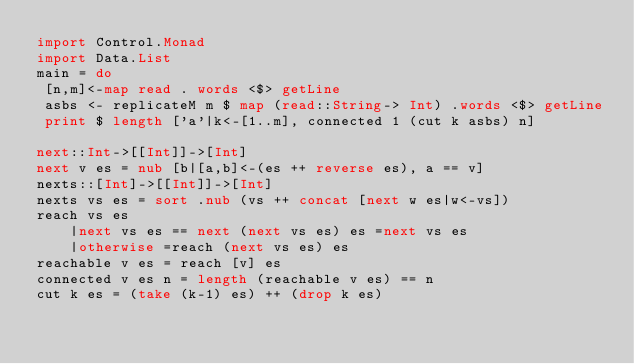<code> <loc_0><loc_0><loc_500><loc_500><_Haskell_>import Control.Monad
import Data.List
main = do
 [n,m]<-map read . words <$> getLine
 asbs <- replicateM m $ map (read::String-> Int) .words <$> getLine
 print $ length ['a'|k<-[1..m], connected 1 (cut k asbs) n]
 
next::Int->[[Int]]->[Int]
next v es = nub [b|[a,b]<-(es ++ reverse es), a == v]
nexts::[Int]->[[Int]]->[Int]
nexts vs es = sort .nub (vs ++ concat [next w es|w<-vs])
reach vs es
	|next vs es == next (next vs es) es =next vs es
    |otherwise =reach (next vs es) es
reachable v es = reach [v] es
connected v es n = length (reachable v es) == n
cut k es = (take (k-1) es) ++ (drop k es) 
</code> 